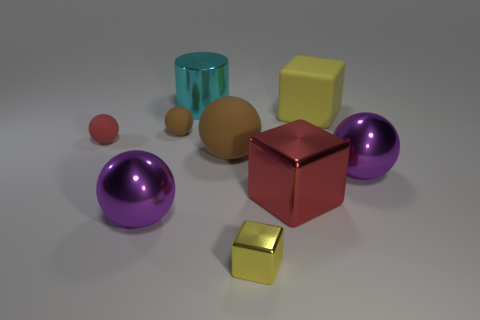There is a purple shiny thing that is left of the yellow thing in front of the large purple metallic thing that is to the left of the large brown rubber sphere; what is its shape?
Offer a very short reply. Sphere. How many gray things are either cylinders or large spheres?
Provide a succinct answer. 0. Are there the same number of big purple balls to the right of the cylinder and big purple objects to the left of the small yellow metallic cube?
Ensure brevity in your answer.  Yes. Does the large metallic object on the left side of the big cylinder have the same shape as the yellow object that is to the right of the large red metallic block?
Your response must be concise. No. Is there any other thing that has the same shape as the small yellow metallic object?
Ensure brevity in your answer.  Yes. What is the shape of the other small object that is the same material as the tiny red thing?
Offer a very short reply. Sphere. Are there the same number of tiny rubber objects that are behind the big red metallic thing and small brown rubber objects?
Your answer should be compact. No. Are the purple ball that is to the left of the big cyan cylinder and the big block in front of the tiny brown sphere made of the same material?
Provide a succinct answer. Yes. What shape is the large cyan metal object to the left of the purple metallic thing to the right of the large cyan metallic cylinder?
Keep it short and to the point. Cylinder. There is a cylinder that is the same material as the big red cube; what color is it?
Your answer should be compact. Cyan. 